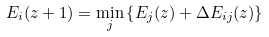Convert formula to latex. <formula><loc_0><loc_0><loc_500><loc_500>E _ { i } ( z + 1 ) = \min _ { j } \left \{ E _ { j } ( z ) + \Delta E _ { i j } ( z ) \right \}</formula> 